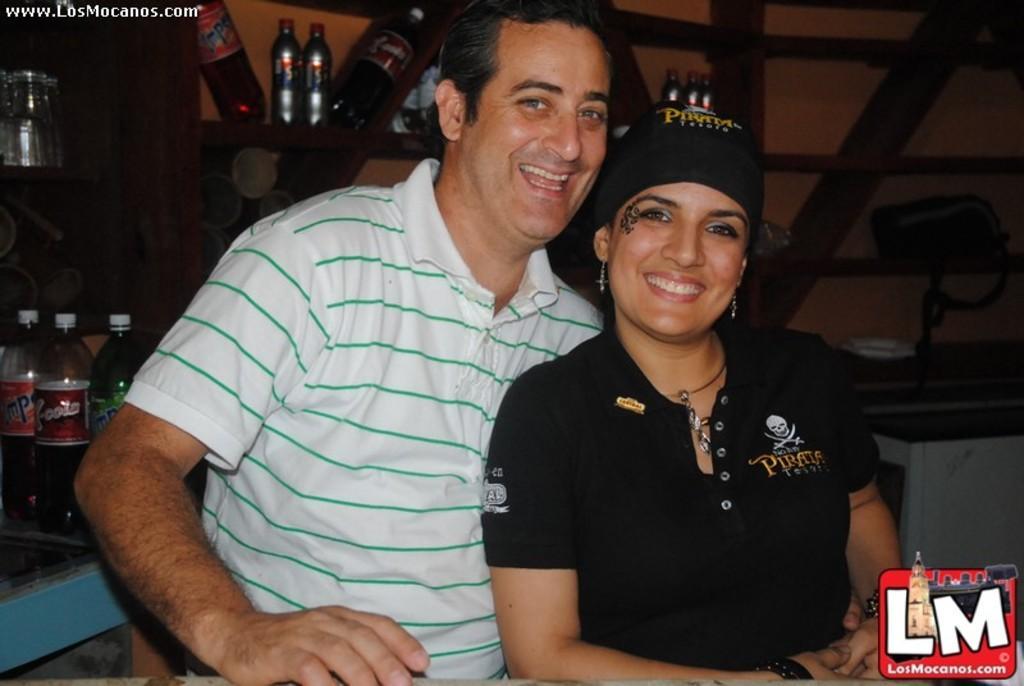In one or two sentences, can you explain what this image depicts? In this image i can see a woman and a man sitting and laughing,at the background i can see few bottles on the wooden rack, a bag. 